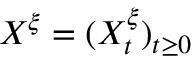<formula> <loc_0><loc_0><loc_500><loc_500>X ^ { \xi } = ( X _ { t } ^ { \xi } ) _ { t \geq 0 }</formula> 